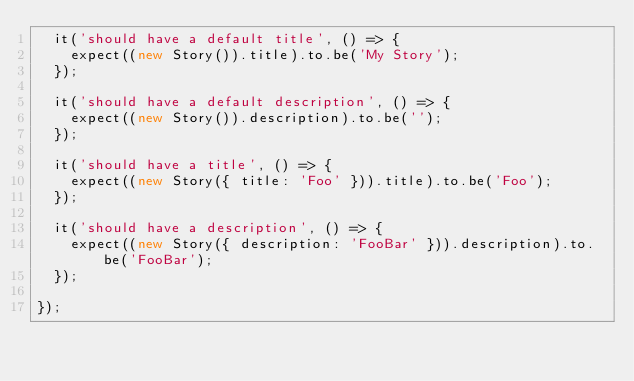<code> <loc_0><loc_0><loc_500><loc_500><_JavaScript_>  it('should have a default title', () => {
    expect((new Story()).title).to.be('My Story');
  });

  it('should have a default description', () => {
    expect((new Story()).description).to.be('');
  });

  it('should have a title', () => {
    expect((new Story({ title: 'Foo' })).title).to.be('Foo');
  });

  it('should have a description', () => {
    expect((new Story({ description: 'FooBar' })).description).to.be('FooBar');
  });

});
</code> 